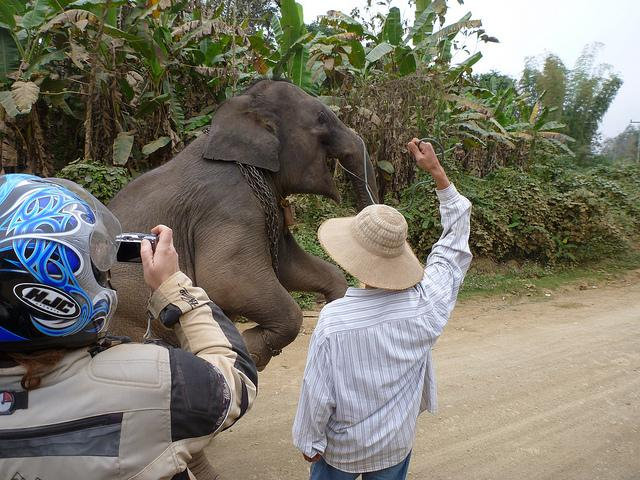Why does the man use a rope? control 